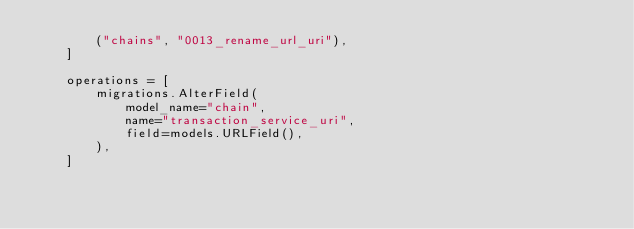<code> <loc_0><loc_0><loc_500><loc_500><_Python_>        ("chains", "0013_rename_url_uri"),
    ]

    operations = [
        migrations.AlterField(
            model_name="chain",
            name="transaction_service_uri",
            field=models.URLField(),
        ),
    ]
</code> 